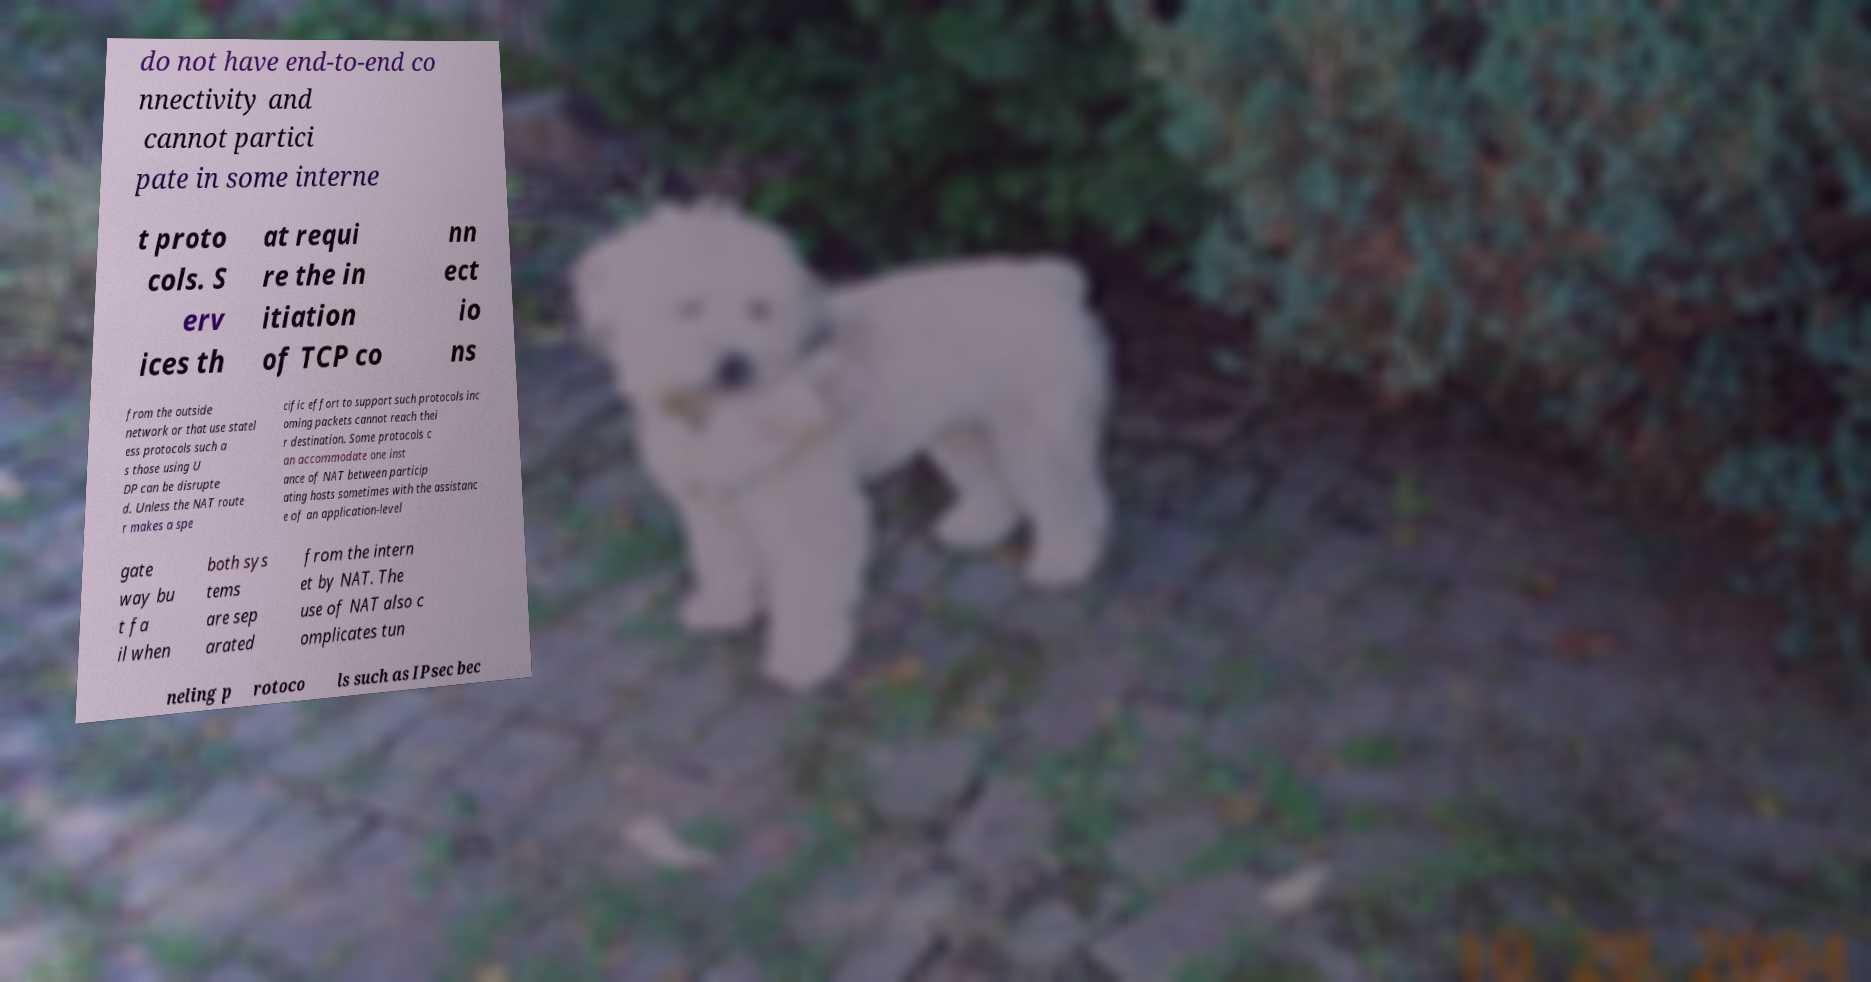There's text embedded in this image that I need extracted. Can you transcribe it verbatim? do not have end-to-end co nnectivity and cannot partici pate in some interne t proto cols. S erv ices th at requi re the in itiation of TCP co nn ect io ns from the outside network or that use statel ess protocols such a s those using U DP can be disrupte d. Unless the NAT route r makes a spe cific effort to support such protocols inc oming packets cannot reach thei r destination. Some protocols c an accommodate one inst ance of NAT between particip ating hosts sometimes with the assistanc e of an application-level gate way bu t fa il when both sys tems are sep arated from the intern et by NAT. The use of NAT also c omplicates tun neling p rotoco ls such as IPsec bec 